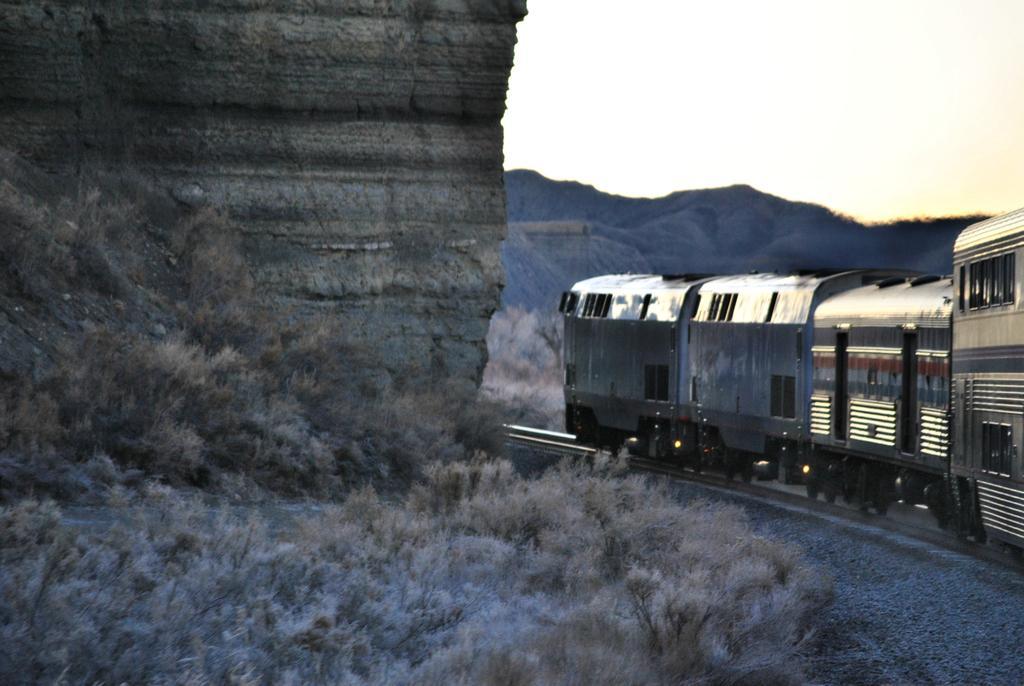In one or two sentences, can you explain what this image depicts? In this picture I can see the train on the railway track. In the background I can see the mountains. At the bottom I can see the grass. At the top right I can see the sky. 